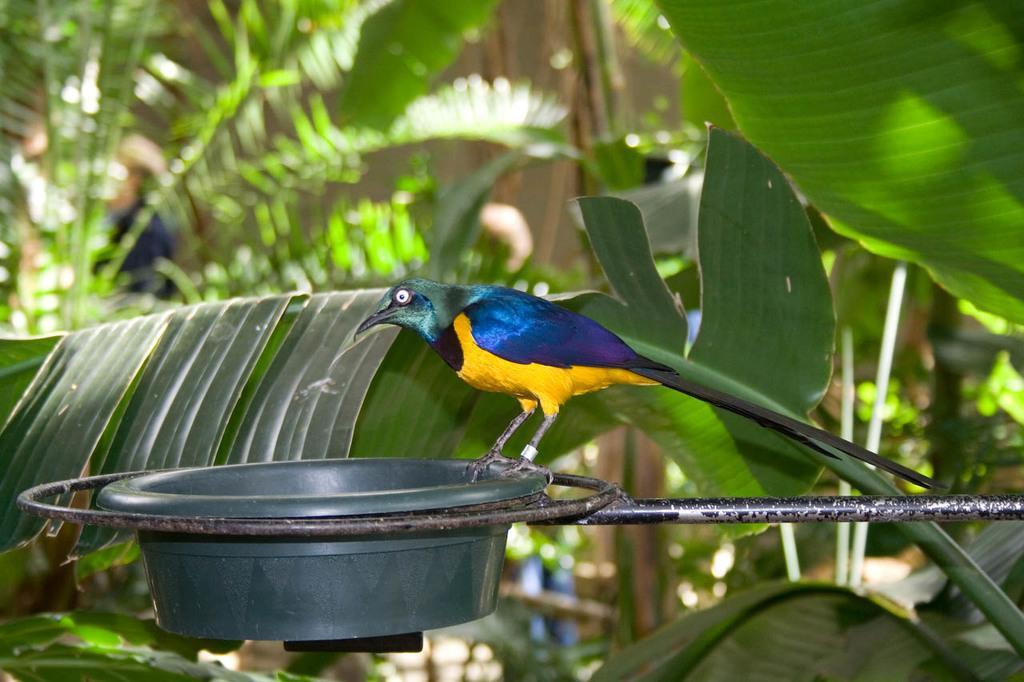In one or two sentences, can you explain what this image depicts? In this image we can see a bird feeder. On that there is a bird. In the back there are leaves. 